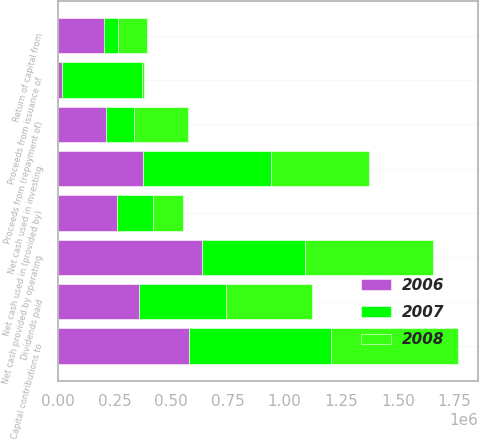Convert chart. <chart><loc_0><loc_0><loc_500><loc_500><stacked_bar_chart><ecel><fcel>Net cash provided by operating<fcel>Return of capital from<fcel>Capital contributions to<fcel>Net cash used in investing<fcel>Proceeds from (repayment of)<fcel>Proceeds from issuance of<fcel>Dividends paid<fcel>Net cash used in (provided by)<nl><fcel>2007<fcel>455388<fcel>64353<fcel>630427<fcel>566074<fcel>125000<fcel>352871<fcel>382283<fcel>159303<nl><fcel>2008<fcel>566688<fcel>129551<fcel>559266<fcel>429715<fcel>238877<fcel>10539<fcel>378892<fcel>134335<nl><fcel>2006<fcel>634128<fcel>201185<fcel>576600<fcel>375415<fcel>211716<fcel>16275<fcel>358746<fcel>259357<nl></chart> 